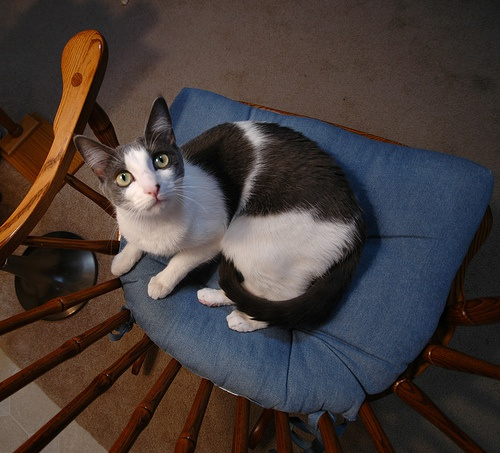Describe the objects in this image and their specific colors. I can see chair in black, darkblue, maroon, and gray tones and cat in black, darkgray, and gray tones in this image. 